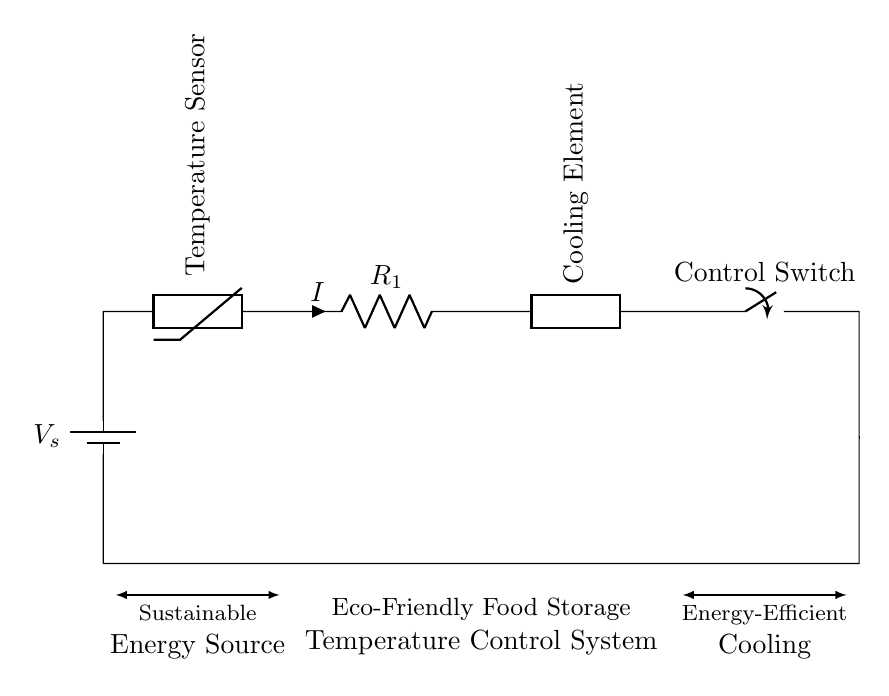What is the type of energy source in this circuit? The diagram shows a battery as the energy source, labeled with V_s, which indicates a voltage supply.
Answer: Battery What component is used to sense temperature? The circuit diagram identifies a thermistor labeled as a temperature sensor, which is designed to detect temperature changes and adjust accordingly.
Answer: Thermistor What is the role of the cooling element in the circuit? The cooling element, marked in the diagram, is responsible for maintaining the temperature of food storage, leveraging energy efficiency to support eco-friendly practices.
Answer: Cooling Element How many resistors are present in the circuit? The circuit features one resistor labeled R_1; therefore, the count of resistors is one.
Answer: One What happens when the control switch is activated? Activating the control switch completes the circuit, allowing current to flow from the battery, through the thermistor and resistor, to the cooling element, thus enabling temperature regulation.
Answer: Current flows What does the arrow labeled 'I' represent in the circuit? The labeled arrow 'I' indicates the direction of current flow, which is determined by the components that create a closed-loop circuit for operation.
Answer: Current What does the circuit indicate about sustainability? The labeling in the diagram reflects a design aimed at sustainable energy use, highlighting the intention to utilize environmentally friendly sources and efficient cooling mechanisms.
Answer: Sustainability 